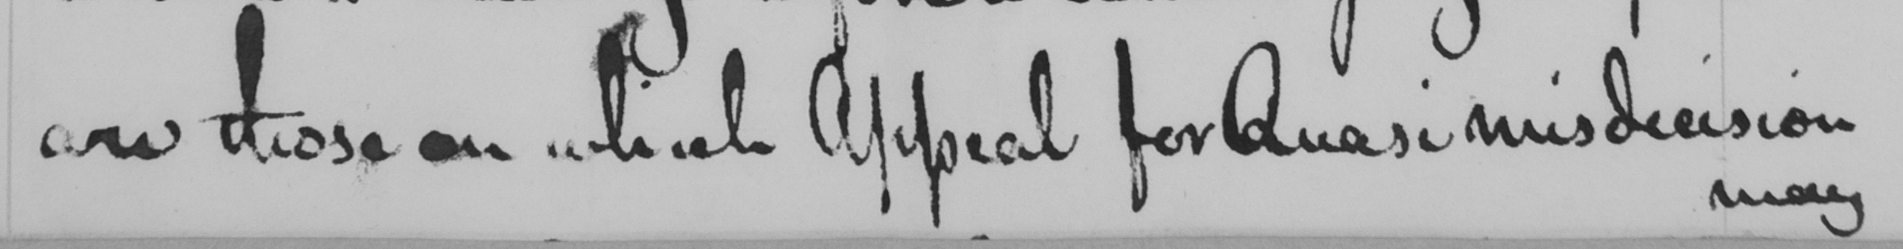Can you read and transcribe this handwriting? are those on which Appeal for Quasi misdecision 